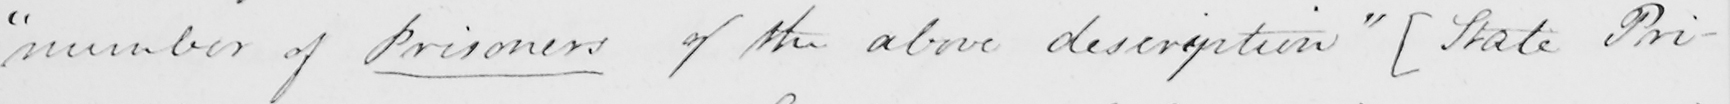Please transcribe the handwritten text in this image. " number of Prisoners of the above description "   [ State Pri- 